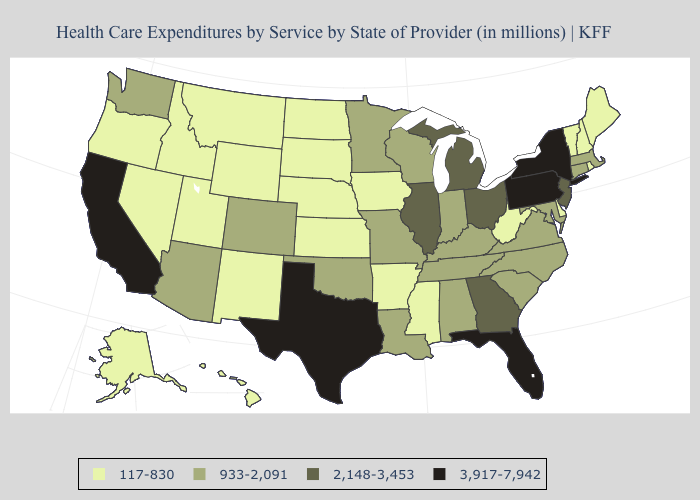Among the states that border Louisiana , does Mississippi have the lowest value?
Give a very brief answer. Yes. What is the value of Idaho?
Concise answer only. 117-830. What is the value of Georgia?
Keep it brief. 2,148-3,453. Name the states that have a value in the range 117-830?
Keep it brief. Alaska, Arkansas, Delaware, Hawaii, Idaho, Iowa, Kansas, Maine, Mississippi, Montana, Nebraska, Nevada, New Hampshire, New Mexico, North Dakota, Oregon, Rhode Island, South Dakota, Utah, Vermont, West Virginia, Wyoming. What is the value of Colorado?
Answer briefly. 933-2,091. Is the legend a continuous bar?
Answer briefly. No. Is the legend a continuous bar?
Give a very brief answer. No. What is the value of Nevada?
Give a very brief answer. 117-830. What is the value of New Hampshire?
Write a very short answer. 117-830. Does Arkansas have the same value as Hawaii?
Concise answer only. Yes. Which states hav the highest value in the MidWest?
Quick response, please. Illinois, Michigan, Ohio. Name the states that have a value in the range 2,148-3,453?
Give a very brief answer. Georgia, Illinois, Michigan, New Jersey, Ohio. Name the states that have a value in the range 117-830?
Concise answer only. Alaska, Arkansas, Delaware, Hawaii, Idaho, Iowa, Kansas, Maine, Mississippi, Montana, Nebraska, Nevada, New Hampshire, New Mexico, North Dakota, Oregon, Rhode Island, South Dakota, Utah, Vermont, West Virginia, Wyoming. What is the value of Texas?
Concise answer only. 3,917-7,942. Does Texas have the highest value in the South?
Write a very short answer. Yes. 